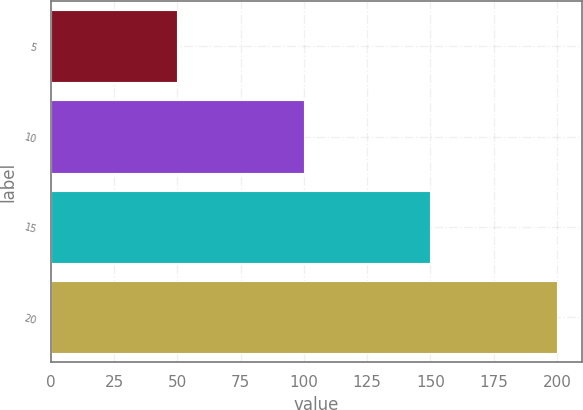Convert chart. <chart><loc_0><loc_0><loc_500><loc_500><bar_chart><fcel>5<fcel>10<fcel>15<fcel>20<nl><fcel>50<fcel>100<fcel>150<fcel>200<nl></chart> 